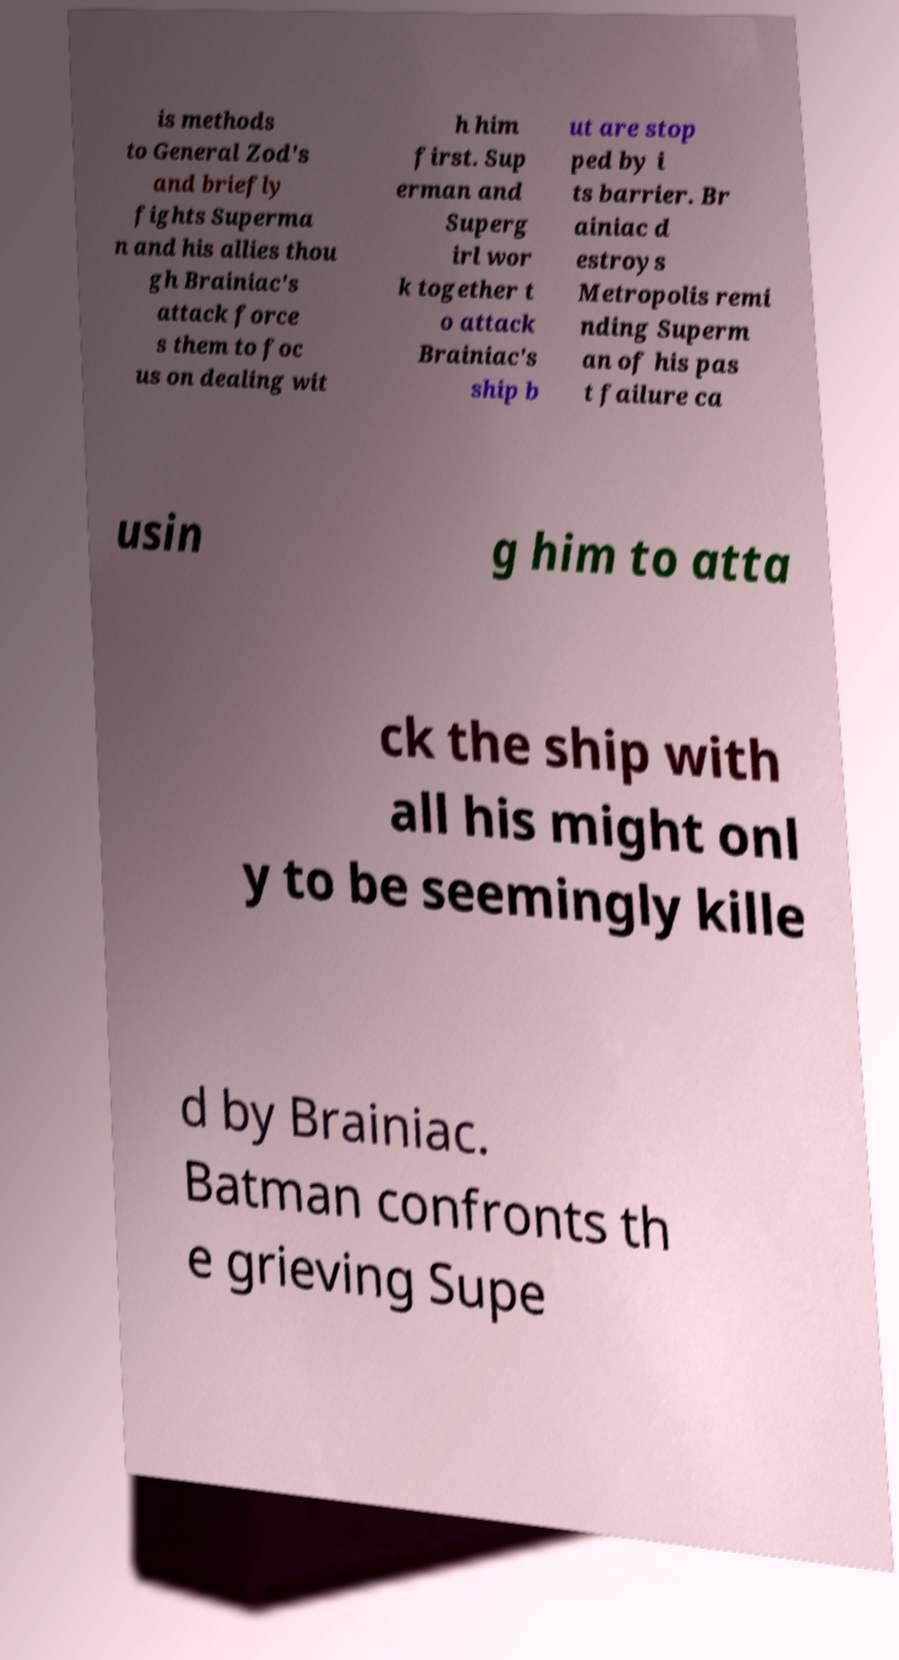Could you assist in decoding the text presented in this image and type it out clearly? is methods to General Zod's and briefly fights Superma n and his allies thou gh Brainiac's attack force s them to foc us on dealing wit h him first. Sup erman and Superg irl wor k together t o attack Brainiac's ship b ut are stop ped by i ts barrier. Br ainiac d estroys Metropolis remi nding Superm an of his pas t failure ca usin g him to atta ck the ship with all his might onl y to be seemingly kille d by Brainiac. Batman confronts th e grieving Supe 